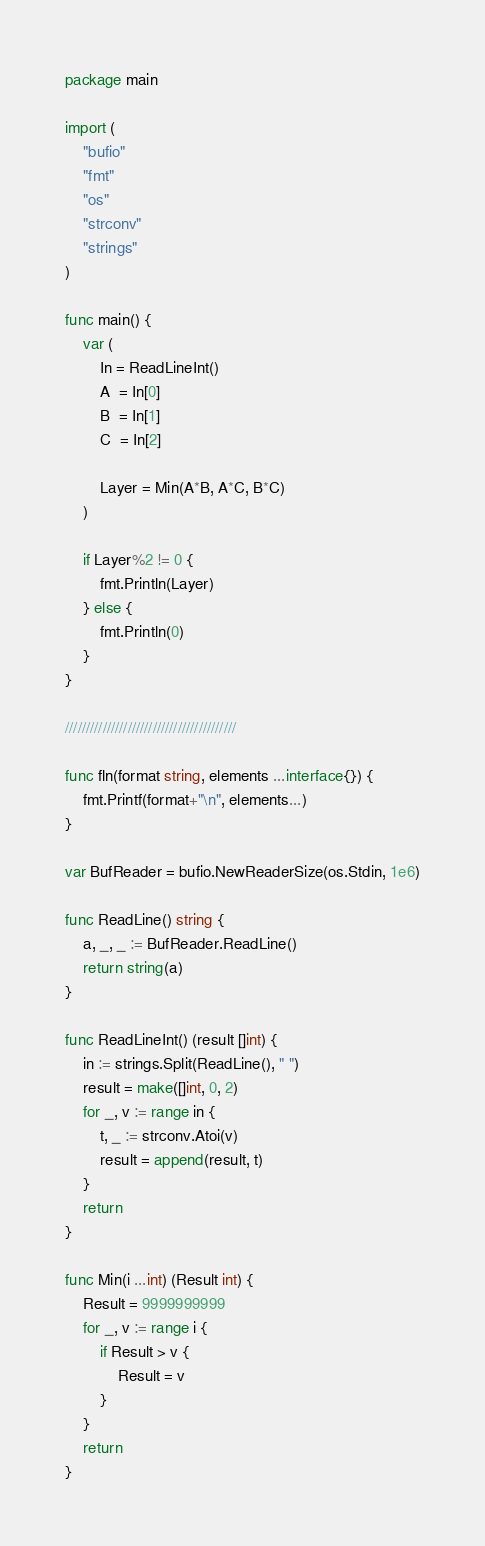Convert code to text. <code><loc_0><loc_0><loc_500><loc_500><_Go_>package main

import (
	"bufio"
	"fmt"
	"os"
	"strconv"
	"strings"
)

func main() {
	var (
		In = ReadLineInt()
		A  = In[0]
		B  = In[1]
		C  = In[2]

		Layer = Min(A*B, A*C, B*C)
	)

	if Layer%2 != 0 {
		fmt.Println(Layer)
	} else {
		fmt.Println(0)
	}
}

/////////////////////////////////////////

func fln(format string, elements ...interface{}) {
	fmt.Printf(format+"\n", elements...)
}

var BufReader = bufio.NewReaderSize(os.Stdin, 1e6)

func ReadLine() string {
	a, _, _ := BufReader.ReadLine()
	return string(a)
}

func ReadLineInt() (result []int) {
	in := strings.Split(ReadLine(), " ")
	result = make([]int, 0, 2)
	for _, v := range in {
		t, _ := strconv.Atoi(v)
		result = append(result, t)
	}
	return
}

func Min(i ...int) (Result int) {
	Result = 9999999999
	for _, v := range i {
		if Result > v {
			Result = v
		}
	}
	return
}
</code> 